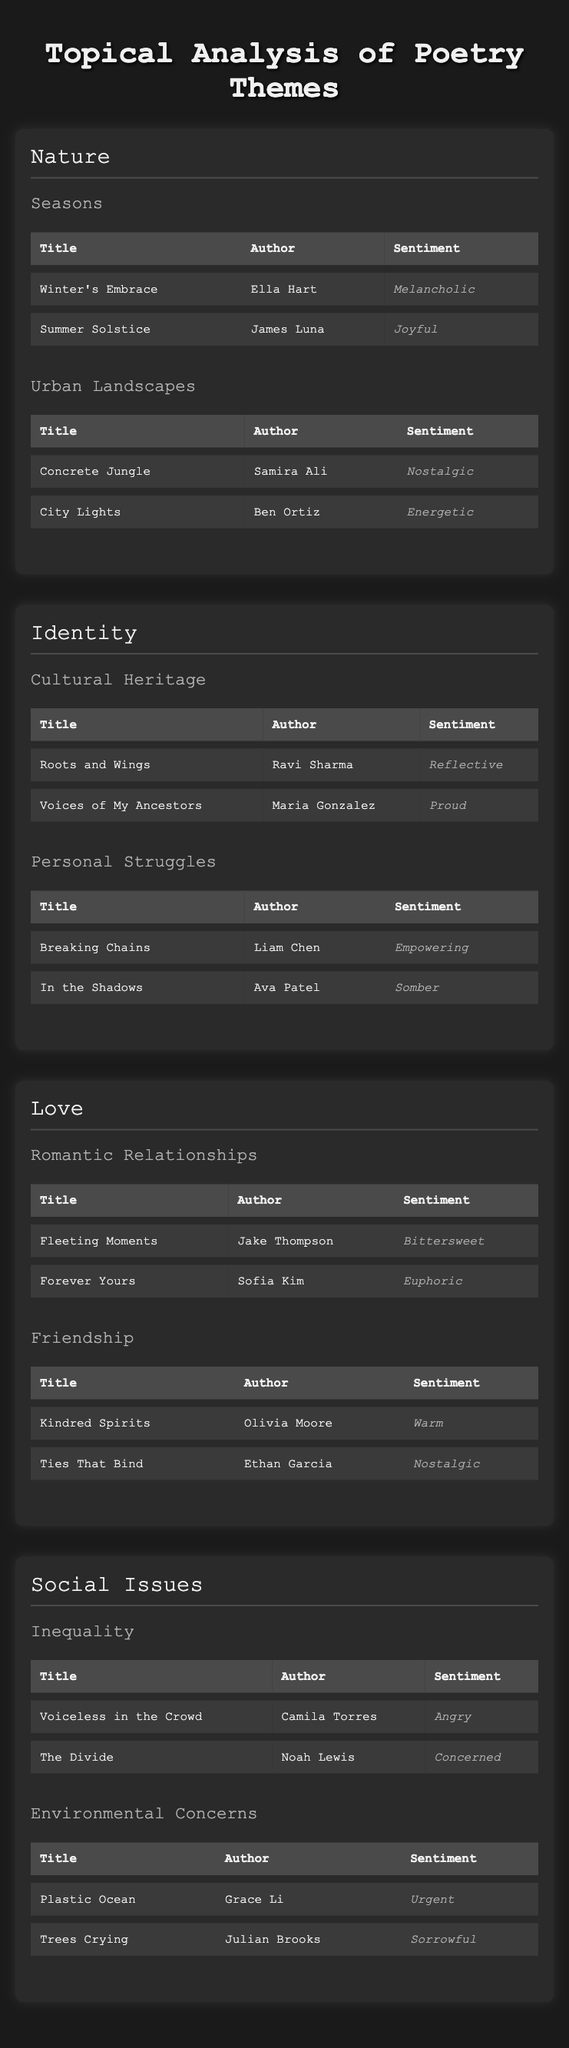What are the titles of the poems under the subtheme "Seasons"? The subtheme "Seasons" includes the poems "Winter's Embrace" by Ella Hart and "Summer Solstice" by James Luna. We can find these titles in the corresponding section of the table.
Answer: Winter's Embrace, Summer Solstice Which author wrote the poem "Plastic Ocean"? The poem "Plastic Ocean" is written by Grace Li. This information is found directly in the Social Issues section under the Environmental Concerns subtheme.
Answer: Grace Li How many poems in the "Identity" theme are titled with a positive sentiment? In the Identity theme, there are two subthemes: Cultural Heritage and Personal Struggles. The poems with positive sentiment are "Roots and Wings" (Reflective) and "Breaking Chains" (Empowering). So, we have two poems with positive sentiment.
Answer: 2 Is "Forever Yours" more joyful than "Fleeting Moments"? "Forever Yours" has a sentiment of Euphoric, while "Fleeting Moments" has a sentiment of Bittersweet. Since Euphoric is a stronger positive sentiment than Bittersweet, we can conclude that "Forever Yours" is indeed more joyful.
Answer: Yes What is the average sentiment type for poems under "Social Issues"? To find this, we need to look at the two subthemes in the Social Issues section: Inequality and Environmental Concerns. The sentiments are Angry, Concerned, Urgent, and Sorrowful. There are four sentiments, but we can't assign a numerical average among qualitative sentiments, although we note the variety.
Answer: Not applicable (qualitative) Which theme has a poem titled "Kindred Spirits"? The poem "Kindred Spirits" is found under the Love theme in the Friendship subtheme. This can be verified by checking the respective section of the table.
Answer: Love Are there more poems under the "Nature" theme than the "Identity" theme? The Nature theme has 4 poems total (2 in Seasons, 2 in Urban Landscapes). The Identity theme has 4 poems as well (2 in Cultural Heritage, 2 in Personal Struggles). Since both themes have an equal number of poems, the answer is no more for either.
Answer: No Which poem in the "Social Issues" theme expresses anger? The poem expressing anger in the Social Issues theme is "Voiceless in the Crowd" authored by Camila Torres. This can be confirmed by reviewing the poems listed under the Inequality subtheme.
Answer: Voiceless in the Crowd 